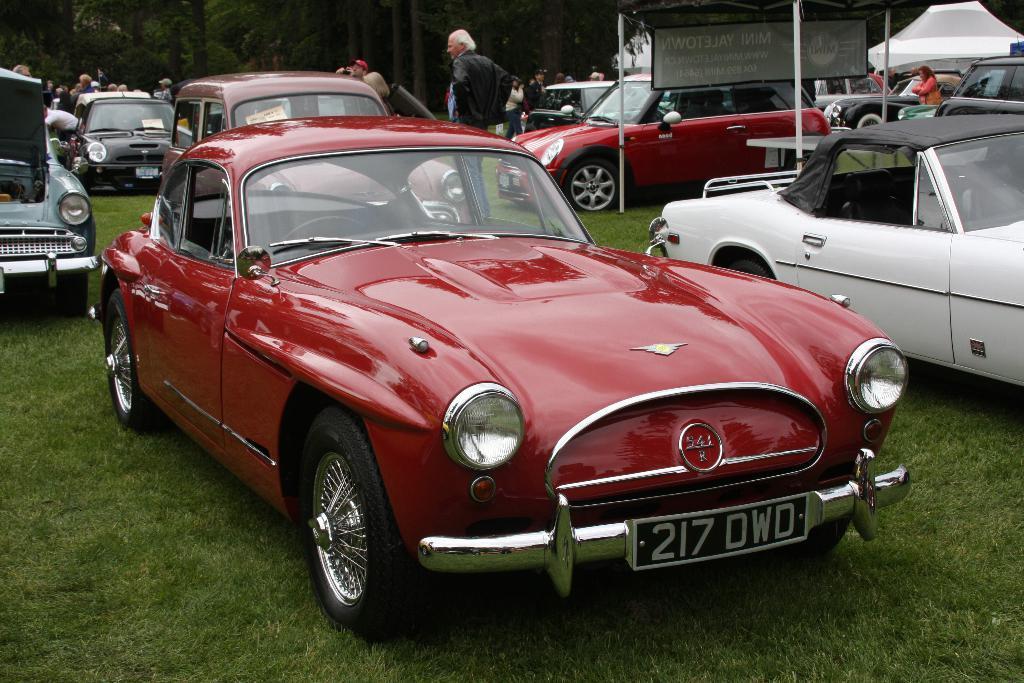Could you give a brief overview of what you see in this image? In this image in front there are cars. At the bottom of the image there is grass on the surface. In the background of the image there are people. There are trees. On the right side of the image there are tents. There is a banner. 